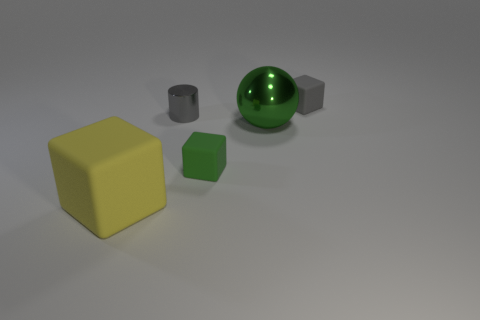What color is the large object that is the same shape as the tiny green object?
Provide a succinct answer. Yellow. There is a block that is behind the green block; is it the same size as the yellow cube?
Make the answer very short. No. How big is the gray object that is on the left side of the thing that is behind the small metal cylinder?
Your answer should be compact. Small. Are the big green object and the small block in front of the tiny gray shiny object made of the same material?
Make the answer very short. No. Is the number of large yellow objects that are behind the small gray cylinder less than the number of large green things on the right side of the gray rubber thing?
Make the answer very short. No. There is a cylinder that is made of the same material as the large green object; what is its color?
Your answer should be compact. Gray. There is a big thing that is behind the yellow rubber object; are there any small gray objects on the left side of it?
Your response must be concise. Yes. The cube that is the same size as the metallic ball is what color?
Offer a terse response. Yellow. How many objects are either yellow objects or gray shiny things?
Ensure brevity in your answer.  2. What is the size of the cube that is on the right side of the small rubber thing on the left side of the tiny matte cube that is to the right of the big metal thing?
Your answer should be compact. Small. 